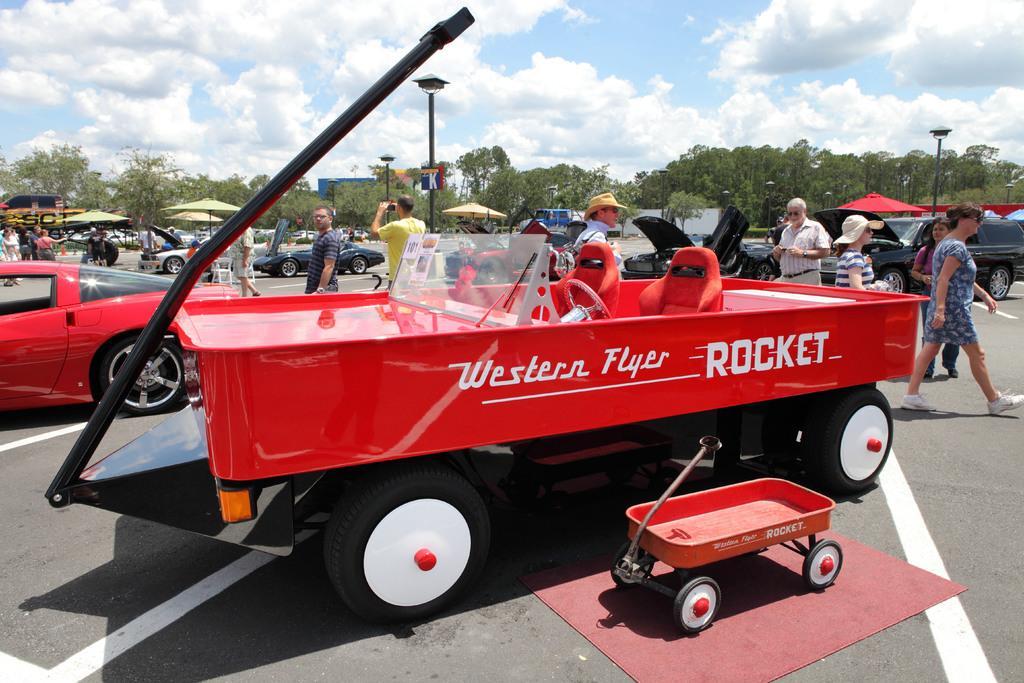In one or two sentences, can you explain what this image depicts? In this image we can see vehicles, cart, mat, people, light poles, signboard and trees. Sky is cloudy. Far there are umbrellas and hoardings. 